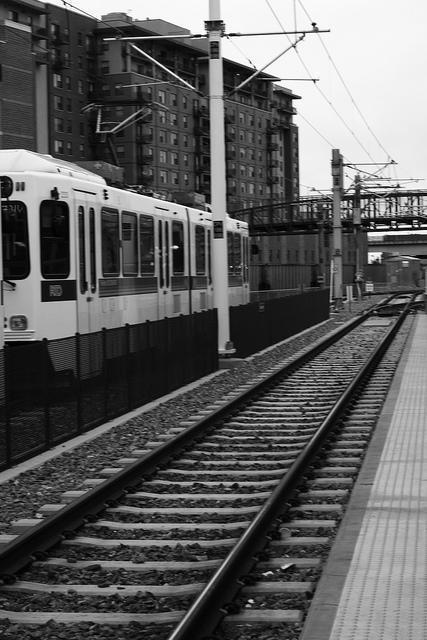How many trains are in the photo?
Give a very brief answer. 1. 